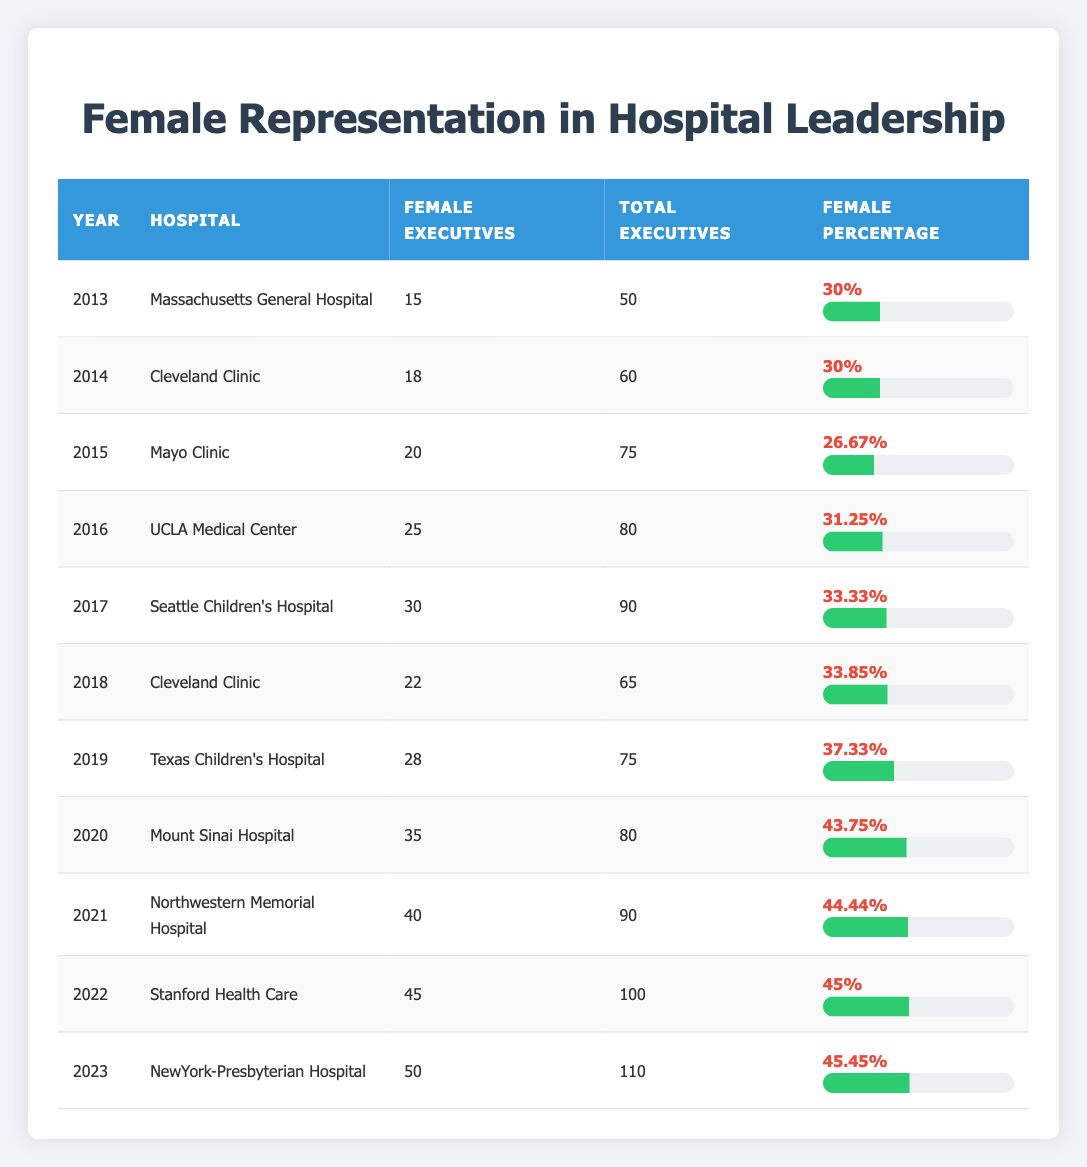What was the percentage of female executives at Massachusetts General Hospital in 2013? The table shows that in 2013, Massachusetts General Hospital had 15 female executives out of a total of 50 executives, which results in a female percentage of 30%.
Answer: 30% Which hospital had the highest percentage of female executives in 2020? In 2020, Mount Sinai Hospital had a female percentage of 43.75%, which is the highest percentage listed for that year when compared to other hospitals.
Answer: Mount Sinai Hospital What is the total number of female executives across all hospitals in 2021? The total number of female executives in 2021 is 40 at Northwestern Memorial Hospital, which is the only data point for that year in the table for female executives.
Answer: 40 Which year's data shows an increase in female percentage compared to the previous year for any hospital? Analyzing the table reveals that from 2019 (37.33%) to 2020 (43.75%), there was an increase in female percentage at Mount Sinai Hospital compared to the previous year.
Answer: Yes What is the average female percentage across all years listed from 2013 to 2023? To find the average, I added all female percentages from 2013 to 2023 (30 + 30 + 30 + 26.67 + 31.25 + 33.33 + 33.85 + 37.33 + 43.75 + 44.44 + 45 + 45.45) =  455.58, and then divided by the total number of years (11), resulting in approximately 41.42%.
Answer: 41.42% What is the difference in the number of female executives between 2022 and 2023? In 2022, there were 45 female executives at Stanford Health Care and in 2023, there were 50 female executives at NewYork-Presbyterian Hospital. The difference is 50 - 45 = 5.
Answer: 5 Did the female representation at Cleveland Clinic remain constant from 2014 to 2018? By checking the data, the female percentage for Cleveland Clinic was 30% in 2014 and 33.85% in 2018, indicating that it increased over that period, rather than remaining constant.
Answer: No Which hospital had the lowest female representation in leadership in 2015? In 2015, Mayo Clinic had the lowest female percentage of 26.67% compared to other hospitals that year, which were higher.
Answer: Mayo Clinic Identify the trend in female representation in the leadership roles from 2013 to 2023. By reviewing the female percentage across the years, it can be observed that the percentage has generally increased from 30% in 2013 to 45.45% in 2023, indicating a positive trend in representation.
Answer: Increasing trend 